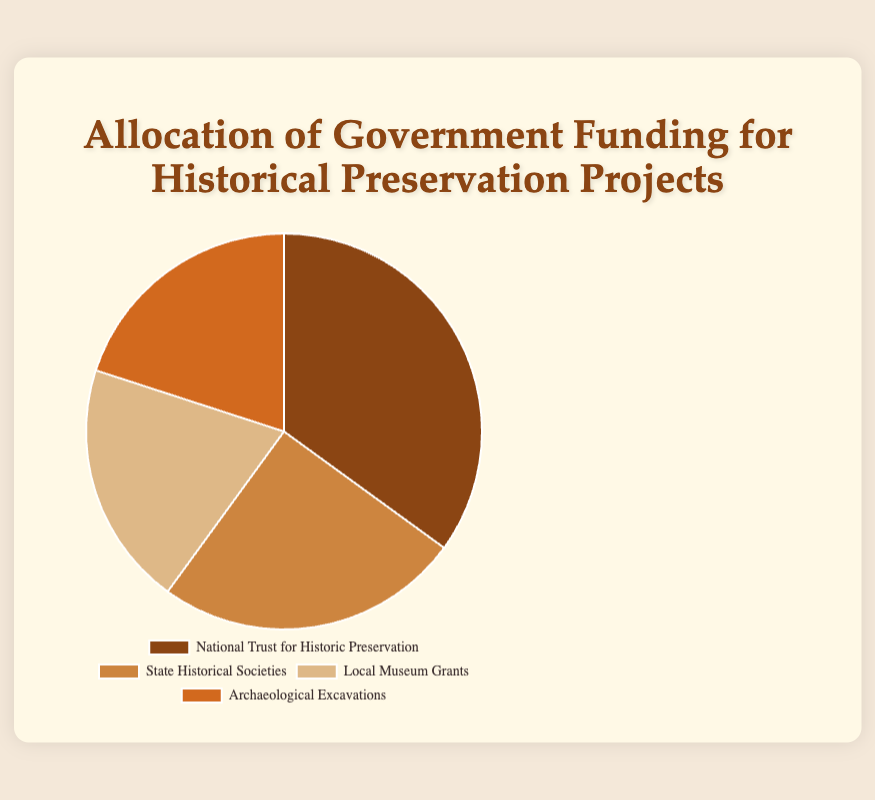Which category receives the highest percentage of funding? By looking at the slices of the pie chart, we can see that the "National Trust for Historic Preservation" has the largest slice, which means it receives the highest percentage.
Answer: National Trust for Historic Preservation What is the combined percentage of funding for Local Museum Grants and Archaeological Excavations? Sum the percentages of the "Local Museum Grants" and "Archaeological Excavations" slices: 20% + 20% = 40%.
Answer: 40% How much more funding does the National Trust for Historic Preservation receive compared to State Historical Societies? Subtract the percentage of State Historical Societies from that of the National Trust for Historic Preservation: 35% - 25% = 10%.
Answer: 10% Which two categories receive an equal percentage of funding? By observing the pie chart, we can identify that "Local Museum Grants" and "Archaeological Excavations" have equal slices, both representing 20% each.
Answer: Local Museum Grants and Archaeological Excavations Which category has the second highest allocation of funding? The slice representing "State Historical Societies" is the second-largest after "National Trust for Historic Preservation."
Answer: State Historical Societies What's the total percentage allocation for National Trust for Historic Preservation and Archaeological Excavations? Sum the percentages of the National Trust for Historic Preservation and Archaeological Excavations: 35% + 20% = 55%.
Answer: 55% What is the visual attribute (color) used to represent the category receiving the highest allocation? The slice representing "National Trust for Historic Preservation" is in brown color, indicating the highest funding percentage.
Answer: Brown If funding for State Historical Societies increased by 5%, what would be their new percentage allocation? Add the increase to the current percentage for State Historical Societies: 25% + 5% = 30%.
Answer: 30% What would be the effect on the pie chart if Local Museum Grants and State Historical Societies' funding amounts were swapped? If the percentages swapped, "Local Museum Grants" would have 25% and "State Historical Societies" would have 20%, resulting in a swap in the size of the corresponding slices.
Answer: Swapped percentages What fraction of the total funding does the category with the least allocation receive? The least allocation is 20%, and in fractions, this would be 20/100, which simplifies to 1/5.
Answer: 1/5 